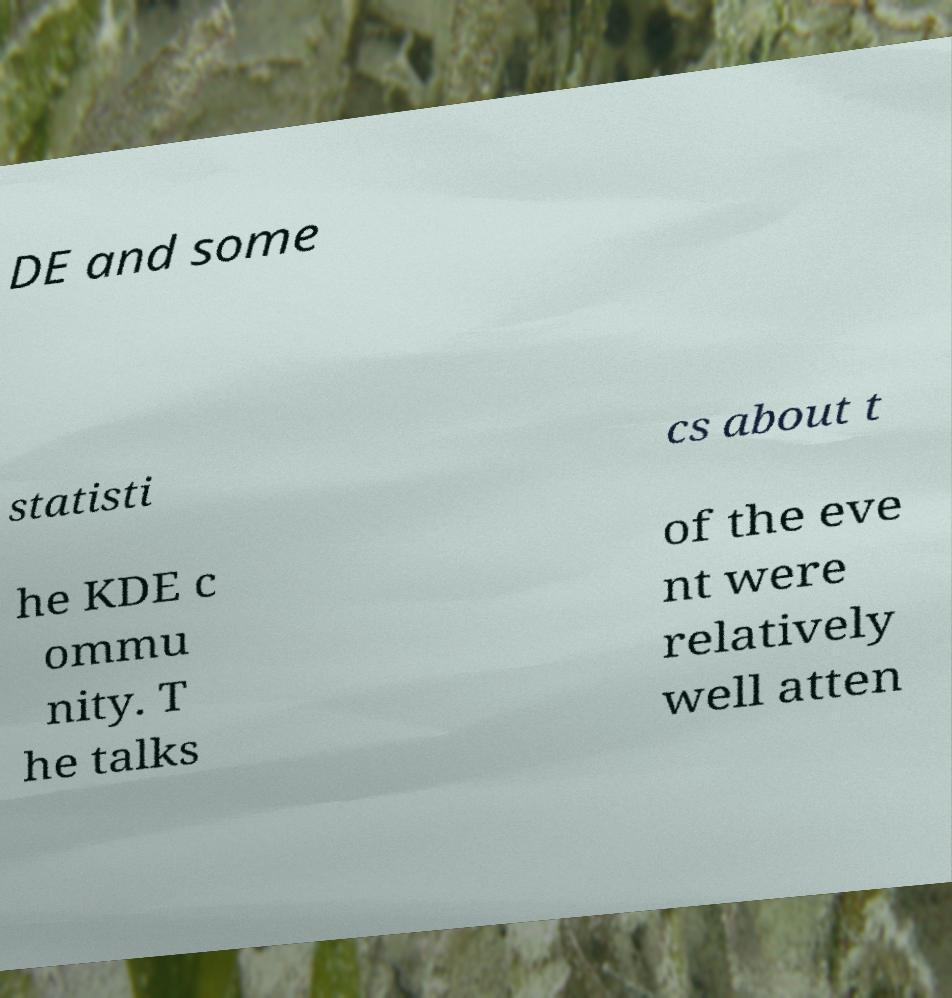There's text embedded in this image that I need extracted. Can you transcribe it verbatim? DE and some statisti cs about t he KDE c ommu nity. T he talks of the eve nt were relatively well atten 